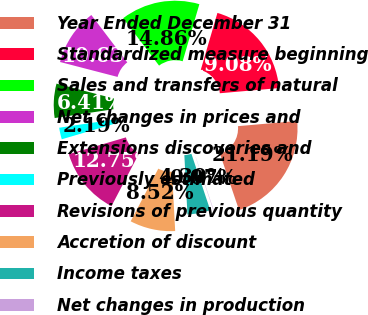Convert chart to OTSL. <chart><loc_0><loc_0><loc_500><loc_500><pie_chart><fcel>Year Ended December 31<fcel>Standardized measure beginning<fcel>Sales and transfers of natural<fcel>Net changes in prices and<fcel>Extensions discoveries and<fcel>Previously estimated<fcel>Revisions of previous quantity<fcel>Accretion of discount<fcel>Income taxes<fcel>Net changes in production<nl><fcel>21.19%<fcel>19.08%<fcel>14.86%<fcel>10.63%<fcel>6.41%<fcel>2.19%<fcel>12.75%<fcel>8.52%<fcel>4.3%<fcel>0.07%<nl></chart> 